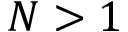<formula> <loc_0><loc_0><loc_500><loc_500>N > 1</formula> 